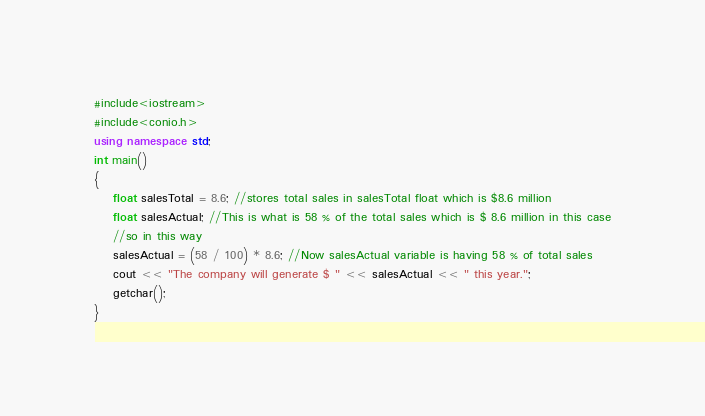Convert code to text. <code><loc_0><loc_0><loc_500><loc_500><_C++_>#include<iostream>
#include<conio.h>
using namespace std;
int main()
{
	float salesTotal = 8.6; //stores total sales in salesTotal float which is $8.6 million
	float salesActual; //This is what is 58 % of the total sales which is $ 8.6 million in this case
	//so in this way
	salesActual = (58 / 100) * 8.6; //Now salesActual variable is having 58 % of total sales
	cout << "The company will generate $ " << salesActual << " this year.";
	getchar();
}</code> 